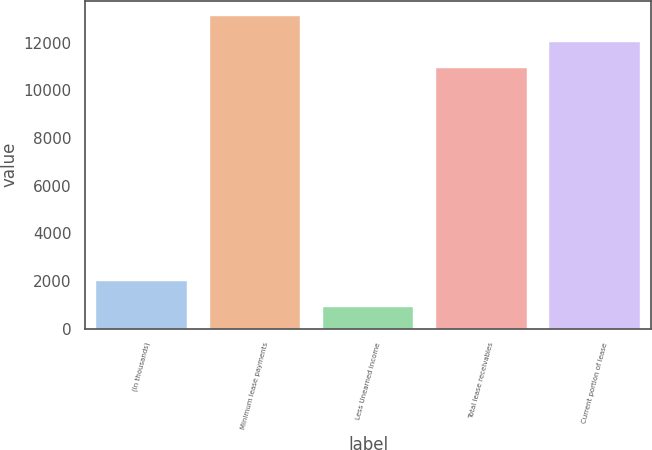Convert chart to OTSL. <chart><loc_0><loc_0><loc_500><loc_500><bar_chart><fcel>(In thousands)<fcel>Minimum lease payments<fcel>Less Unearned income<fcel>Total lease receivables<fcel>Current portion of lease<nl><fcel>2018.8<fcel>13113.6<fcel>926<fcel>10928<fcel>12020.8<nl></chart> 